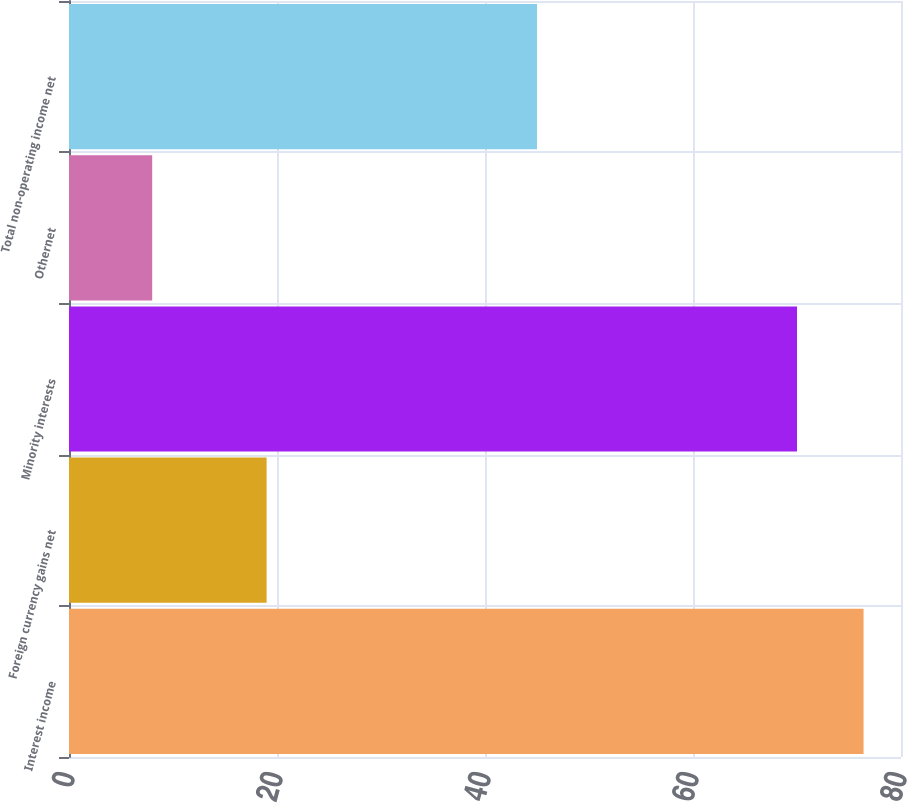Convert chart. <chart><loc_0><loc_0><loc_500><loc_500><bar_chart><fcel>Interest income<fcel>Foreign currency gains net<fcel>Minority interests<fcel>Othernet<fcel>Total non-operating income net<nl><fcel>76.4<fcel>19<fcel>70<fcel>8<fcel>45<nl></chart> 